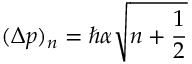<formula> <loc_0><loc_0><loc_500><loc_500>( \Delta p ) _ { n } = \hbar { \alpha } \sqrt { n + \frac { 1 } { 2 } }</formula> 